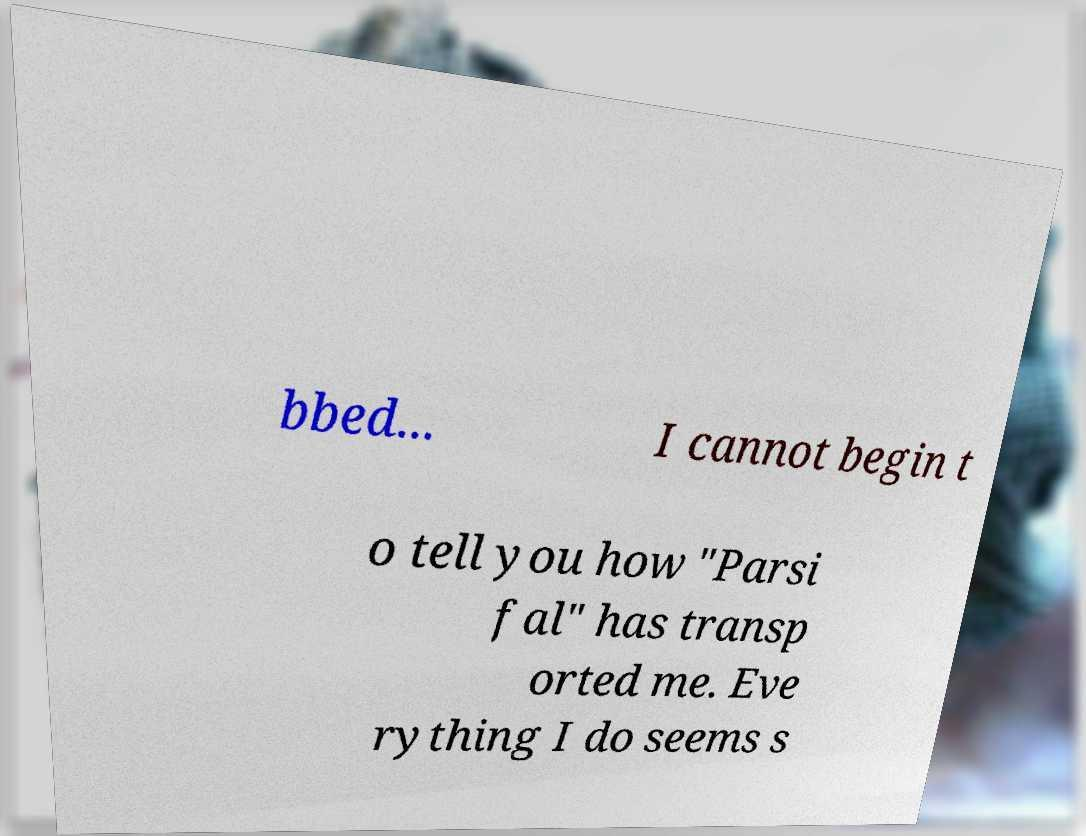Can you accurately transcribe the text from the provided image for me? bbed... I cannot begin t o tell you how "Parsi fal" has transp orted me. Eve rything I do seems s 